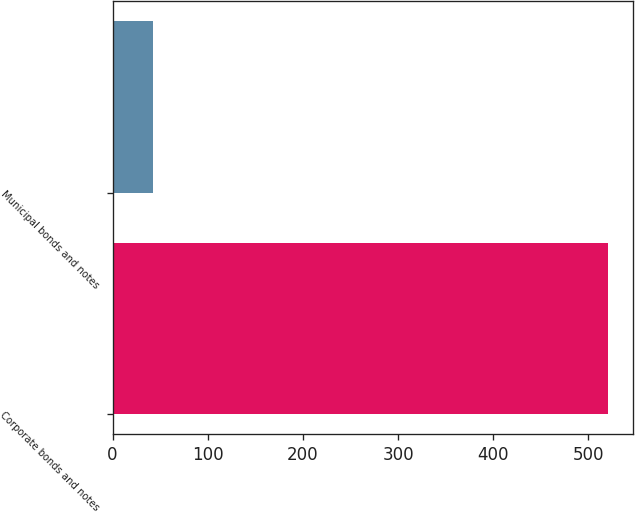Convert chart to OTSL. <chart><loc_0><loc_0><loc_500><loc_500><bar_chart><fcel>Corporate bonds and notes<fcel>Municipal bonds and notes<nl><fcel>521<fcel>42<nl></chart> 